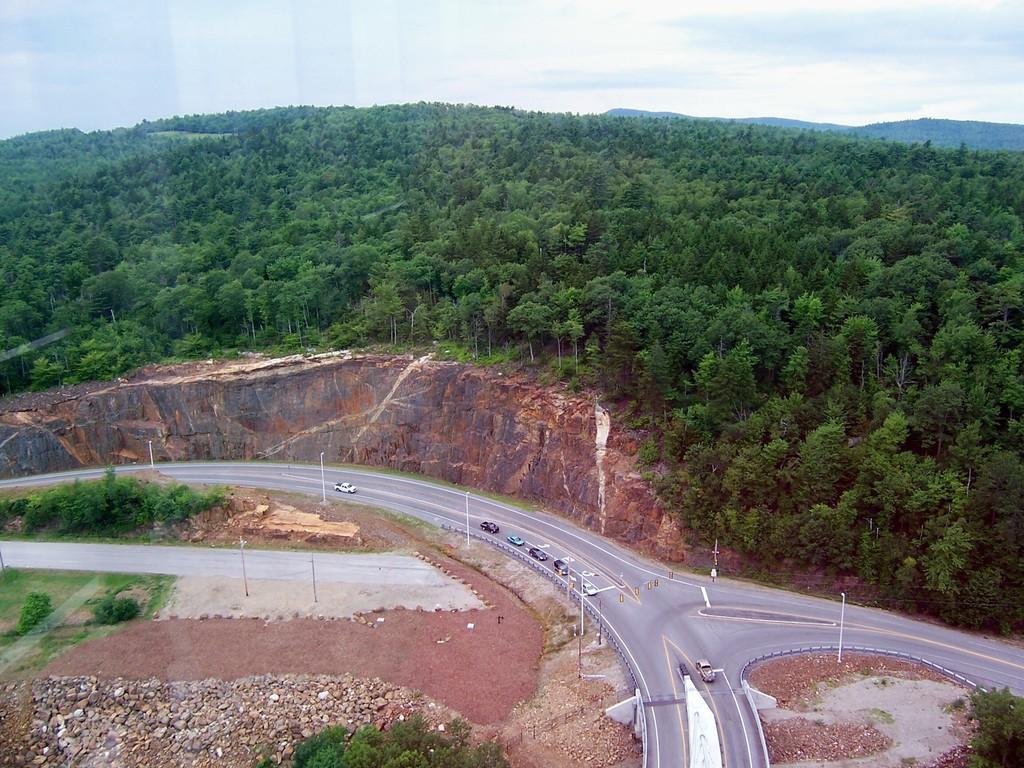Can you describe this image briefly? In this image I can see few vehicles are on the road. To the side of the road I can see many poles, stones, plants and also rock. In the background I can see many trees, clouds and the sky. 